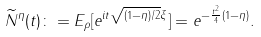Convert formula to latex. <formula><loc_0><loc_0><loc_500><loc_500>\widetilde { N } ^ { \eta } ( t ) \colon = E _ { \rho } [ e ^ { i t \sqrt { ( 1 - \eta ) / 2 } \xi } ] = e ^ { - \frac { t ^ { 2 } } { 4 } ( 1 - \eta ) } .</formula> 